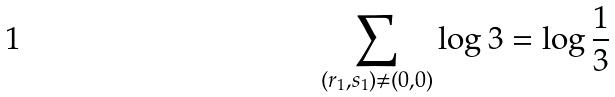<formula> <loc_0><loc_0><loc_500><loc_500>\sum _ { ( r _ { 1 } , s _ { 1 } ) \neq ( 0 , 0 ) } \log { 3 } = \log \frac { 1 } { 3 }</formula> 